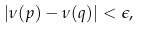<formula> <loc_0><loc_0><loc_500><loc_500>| \nu ( p ) - \nu ( q ) | < \epsilon ,</formula> 